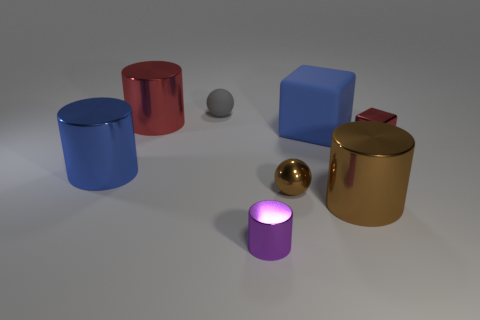Subtract 1 cylinders. How many cylinders are left? 3 Add 1 gray objects. How many objects exist? 9 Subtract all blocks. How many objects are left? 6 Subtract all small yellow objects. Subtract all matte blocks. How many objects are left? 7 Add 5 small purple things. How many small purple things are left? 6 Add 4 brown things. How many brown things exist? 6 Subtract 0 cyan spheres. How many objects are left? 8 